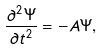Convert formula to latex. <formula><loc_0><loc_0><loc_500><loc_500>\frac { \partial ^ { 2 } \Psi } { \partial t ^ { 2 } } = - A \Psi ,</formula> 